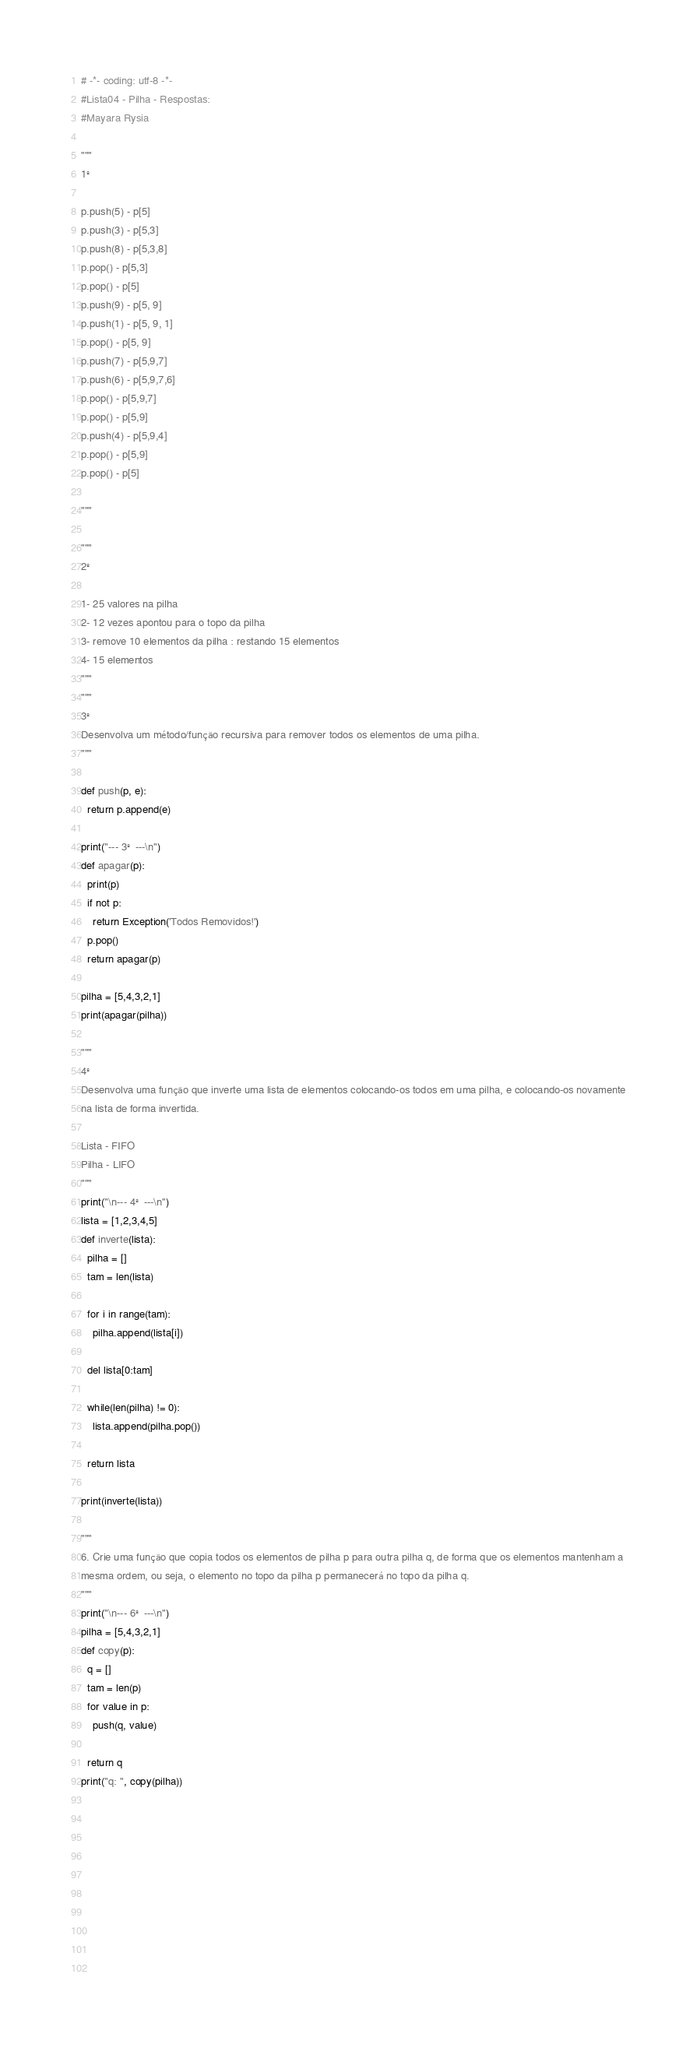<code> <loc_0><loc_0><loc_500><loc_500><_Python_># -*- coding: utf-8 -*-
#Lista04 - Pilha - Respostas:
#Mayara Rysia

"""
1º

p.push(5) - p[5]
p.push(3) - p[5,3]
p.push(8) - p[5,3,8]
p.pop() - p[5,3]
p.pop() - p[5]
p.push(9) - p[5, 9]
p.push(1) - p[5, 9, 1]
p.pop() - p[5, 9]
p.push(7) - p[5,9,7]
p.push(6) - p[5,9,7,6]
p.pop() - p[5,9,7]
p.pop() - p[5,9]
p.push(4) - p[5,9,4]
p.pop() - p[5,9]
p.pop() - p[5]

"""

"""
2º

1- 25 valores na pilha
2- 12 vezes apontou para o topo da pilha
3- remove 10 elementos da pilha : restando 15 elementos
4- 15 elementos
"""
"""
3º
Desenvolva um método/função recursiva para remover todos os elementos de uma pilha.
"""

def push(p, e):
  return p.append(e)
  
print("--- 3º ---\n")
def apagar(p):
  print(p)
  if not p:
    return Exception('Todos Removidos!')
  p.pop()
  return apagar(p)

pilha = [5,4,3,2,1]
print(apagar(pilha))

"""
4º
Desenvolva uma função que inverte uma lista de elementos colocando-os todos em uma pilha, e colocando-os novamente
na lista de forma invertida.

Lista - FIFO
Pilha - LIFO
"""
print("\n--- 4º ---\n")
lista = [1,2,3,4,5]
def inverte(lista):
  pilha = []
  tam = len(lista)
  
  for i in range(tam):
    pilha.append(lista[i])
    
  del lista[0:tam]
  
  while(len(pilha) != 0):
    lista.append(pilha.pop())
 
  return lista
 
print(inverte(lista))
  
"""
6. Crie uma função que copia todos os elementos de pilha p para outra pilha q, de forma que os elementos mantenham a
mesma ordem, ou seja, o elemento no topo da pilha p permanecerá no topo da pilha q.
"""
print("\n--- 6º ---\n")
pilha = [5,4,3,2,1]
def copy(p):
  q = []
  tam = len(p)
  for value in p:
    push(q, value)
  
  return q
print("q: ", copy(pilha))
   
  
  
  
  
  
  
  
  
  
</code> 